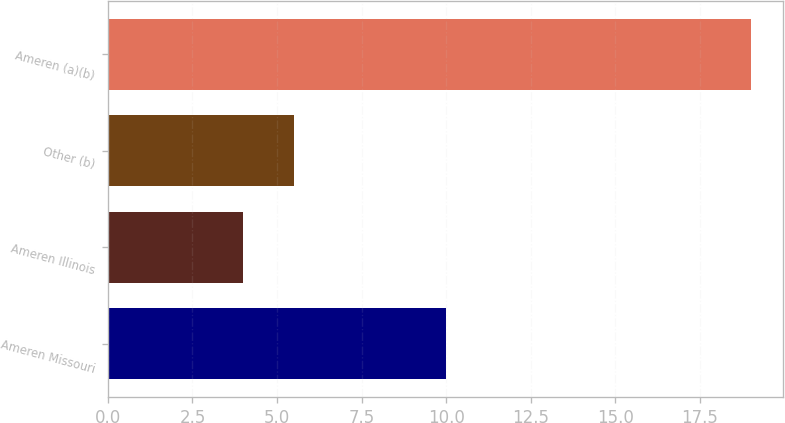<chart> <loc_0><loc_0><loc_500><loc_500><bar_chart><fcel>Ameren Missouri<fcel>Ameren Illinois<fcel>Other (b)<fcel>Ameren (a)(b)<nl><fcel>10<fcel>4<fcel>5.5<fcel>19<nl></chart> 